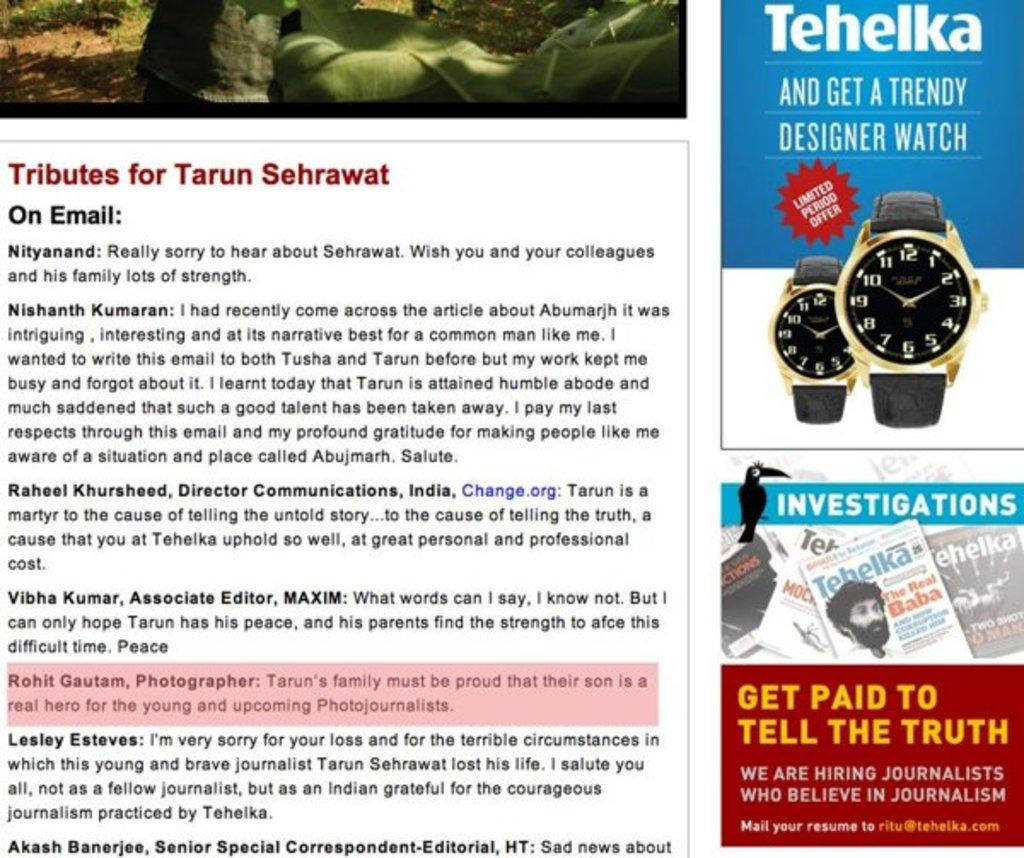<image>
Share a concise interpretation of the image provided. A page is titled Tributes for Tarun Sehrawat. 